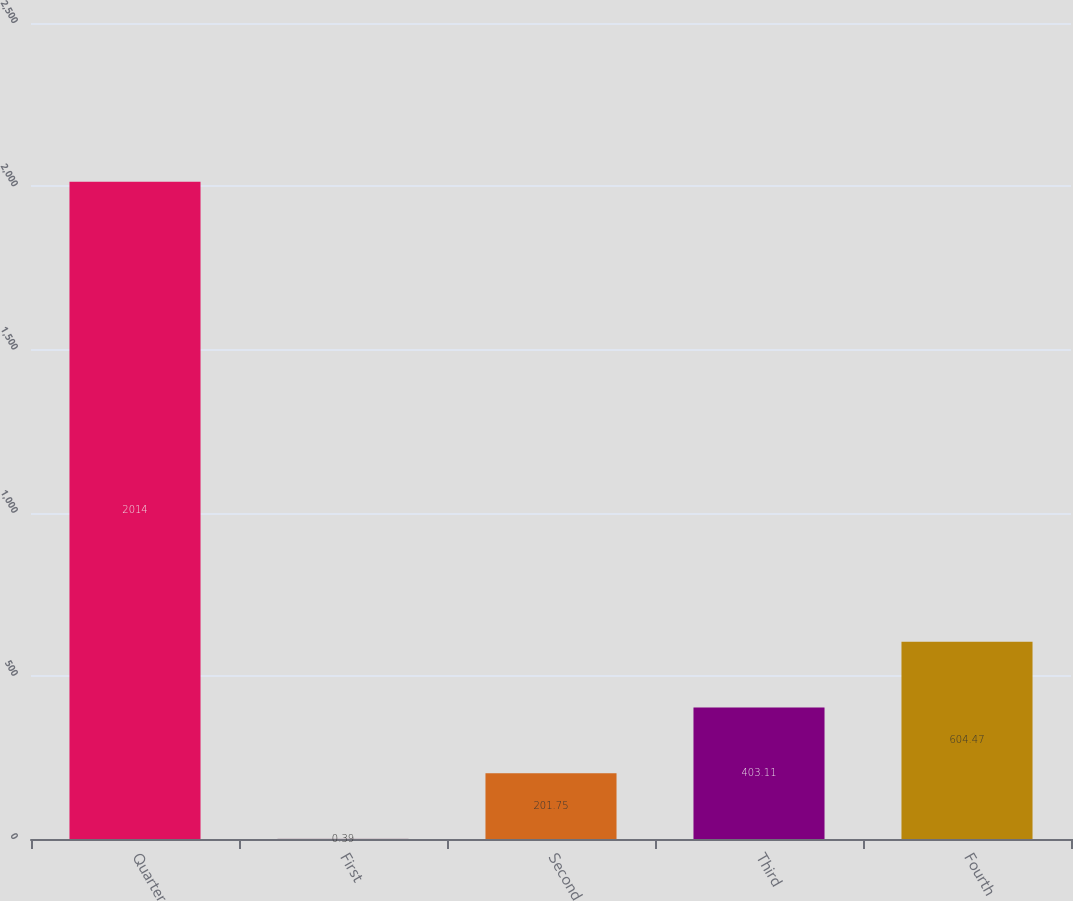Convert chart to OTSL. <chart><loc_0><loc_0><loc_500><loc_500><bar_chart><fcel>Quarter<fcel>First<fcel>Second<fcel>Third<fcel>Fourth<nl><fcel>2014<fcel>0.39<fcel>201.75<fcel>403.11<fcel>604.47<nl></chart> 